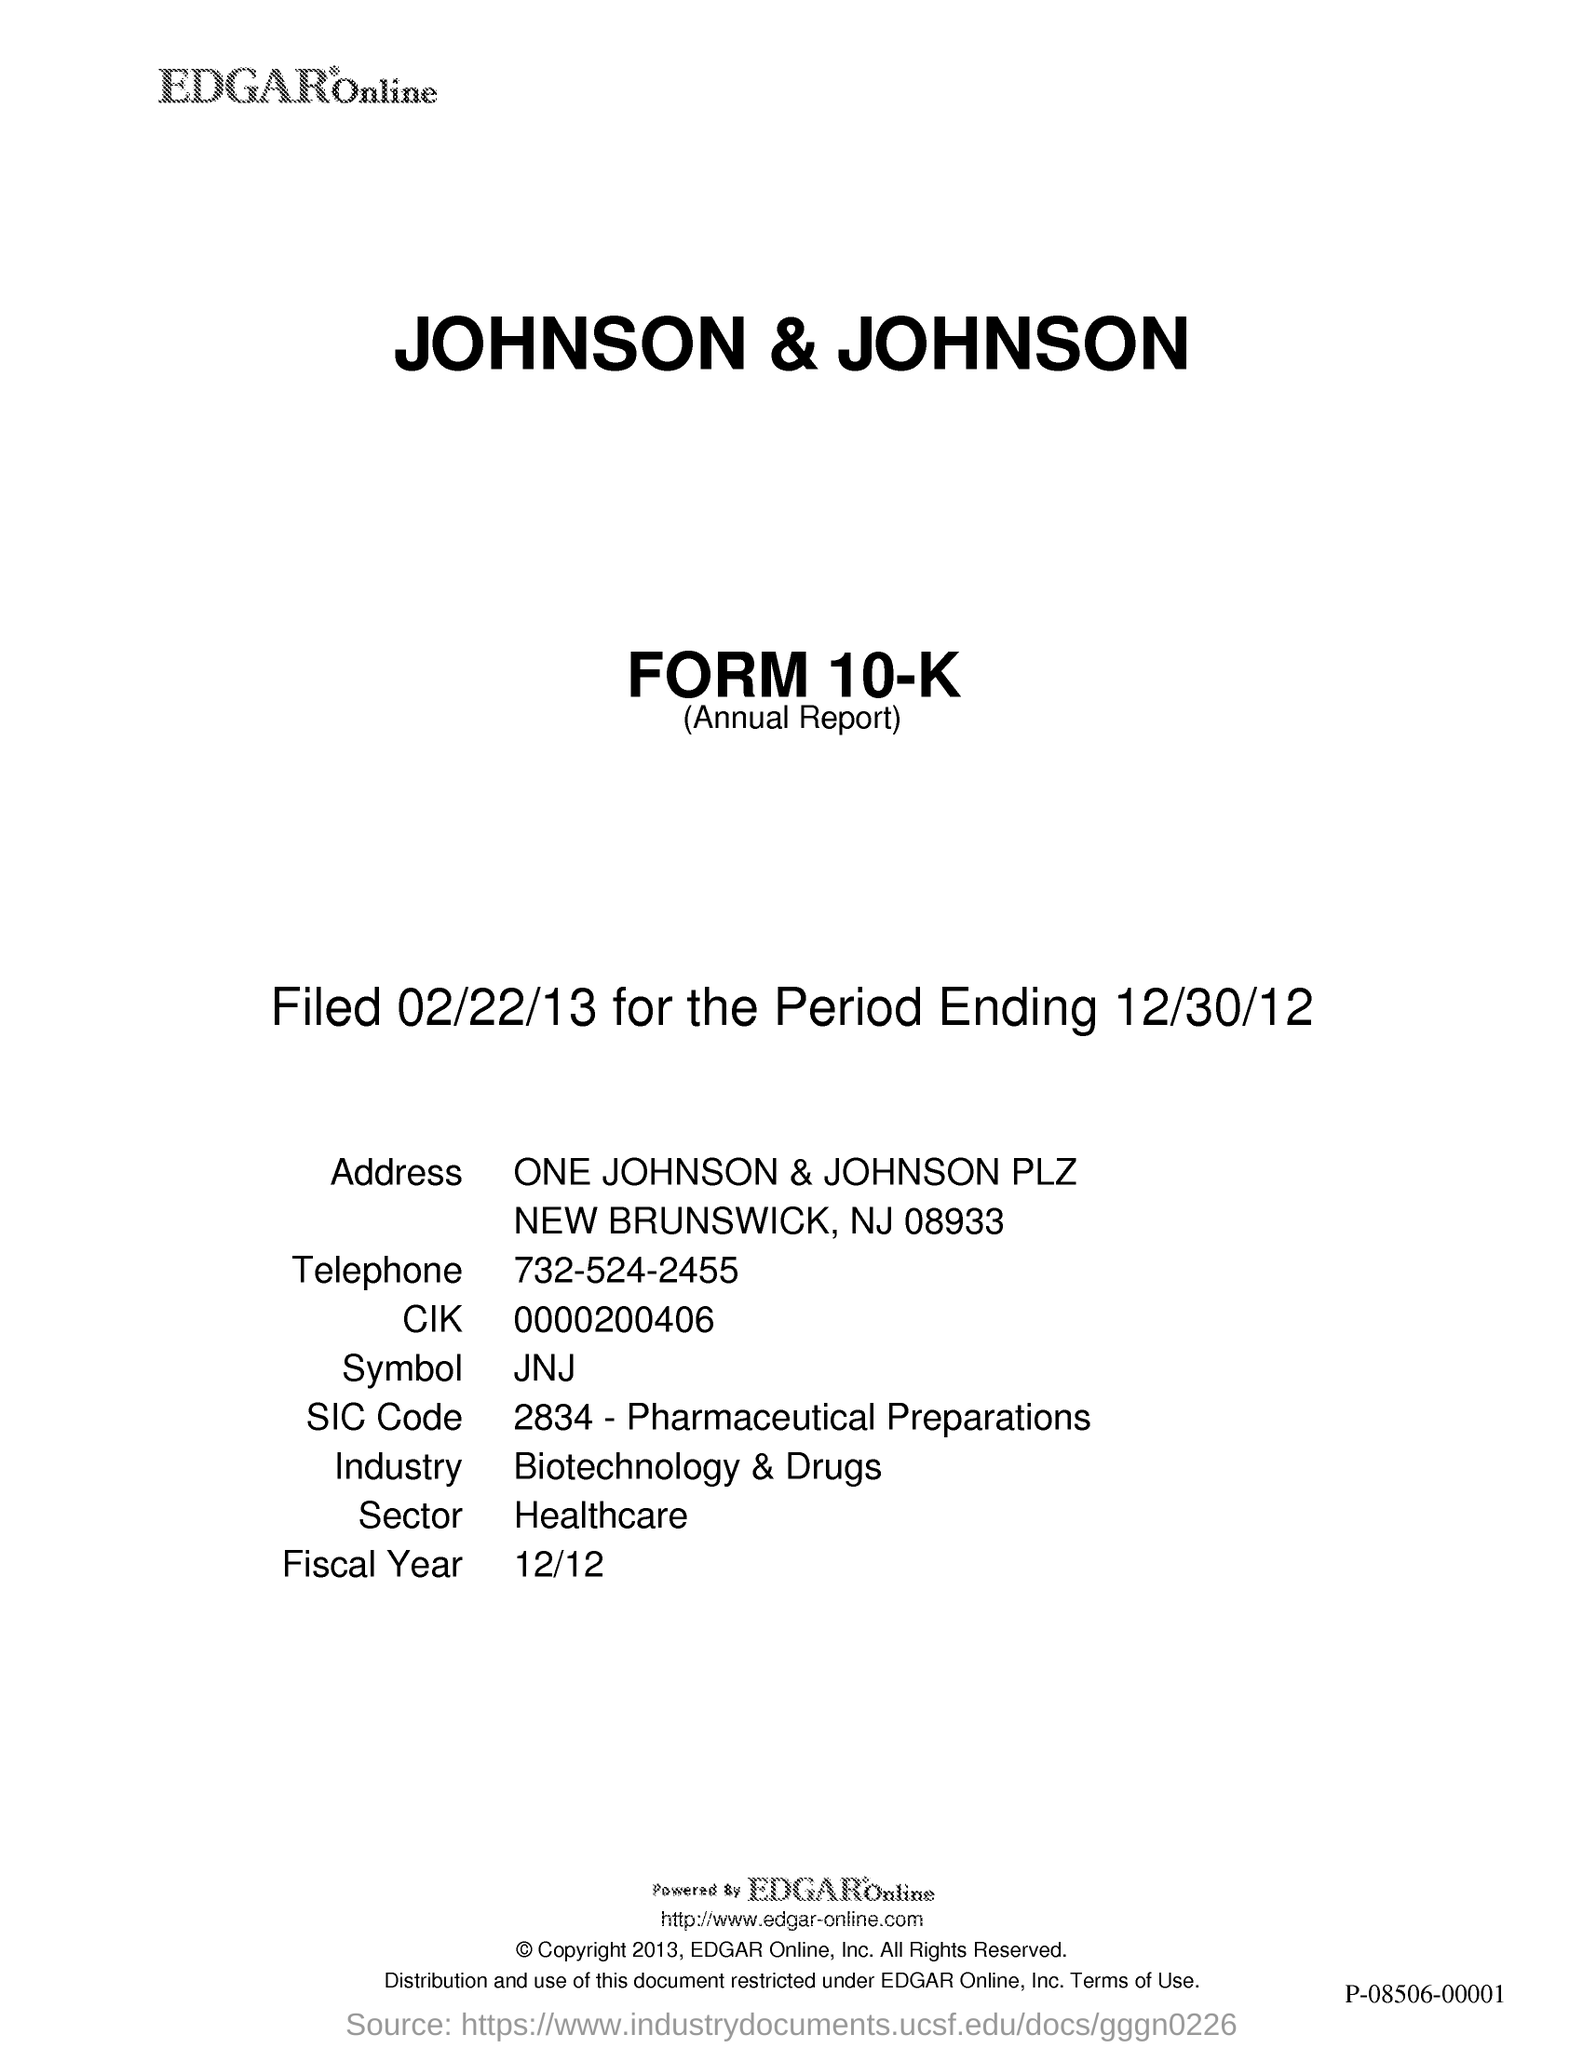Point out several critical features in this image. The fiscal year mentioned in the document is 12/12. The telephone number given in this document is 732-524-2455. Johnson & Johnson is a company that belongs to the healthcare sector. Johnson & Johnson is a company that operates within the industry of biotechnology and pharmaceuticals. 